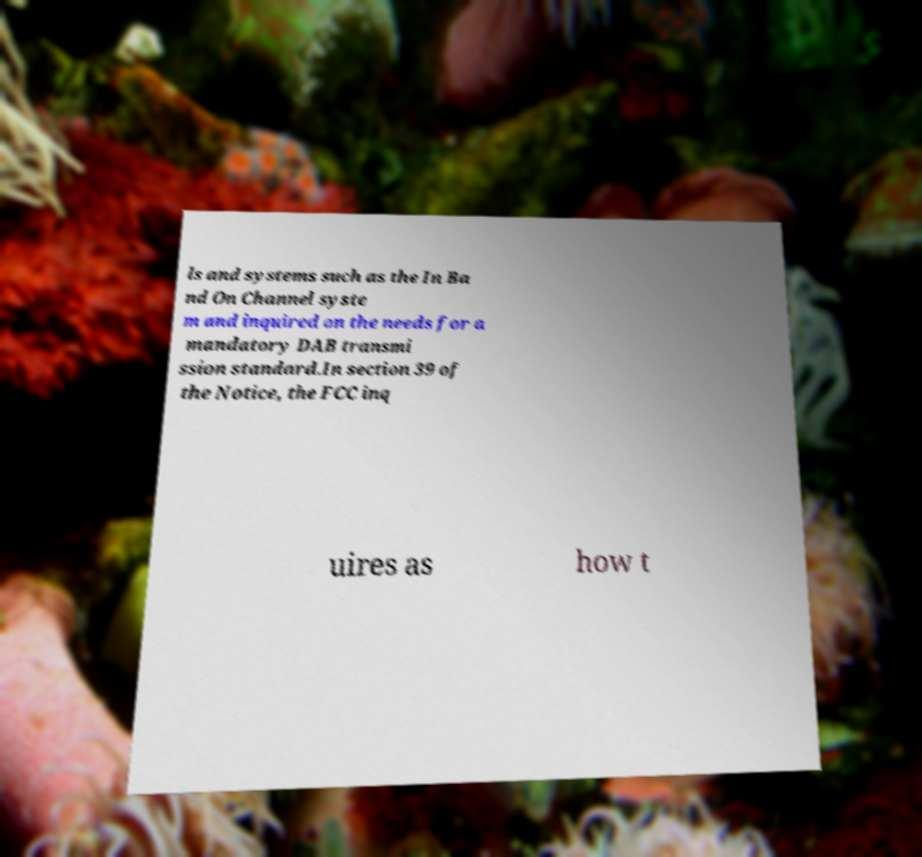I need the written content from this picture converted into text. Can you do that? ls and systems such as the In Ba nd On Channel syste m and inquired on the needs for a mandatory DAB transmi ssion standard.In section 39 of the Notice, the FCC inq uires as how t 